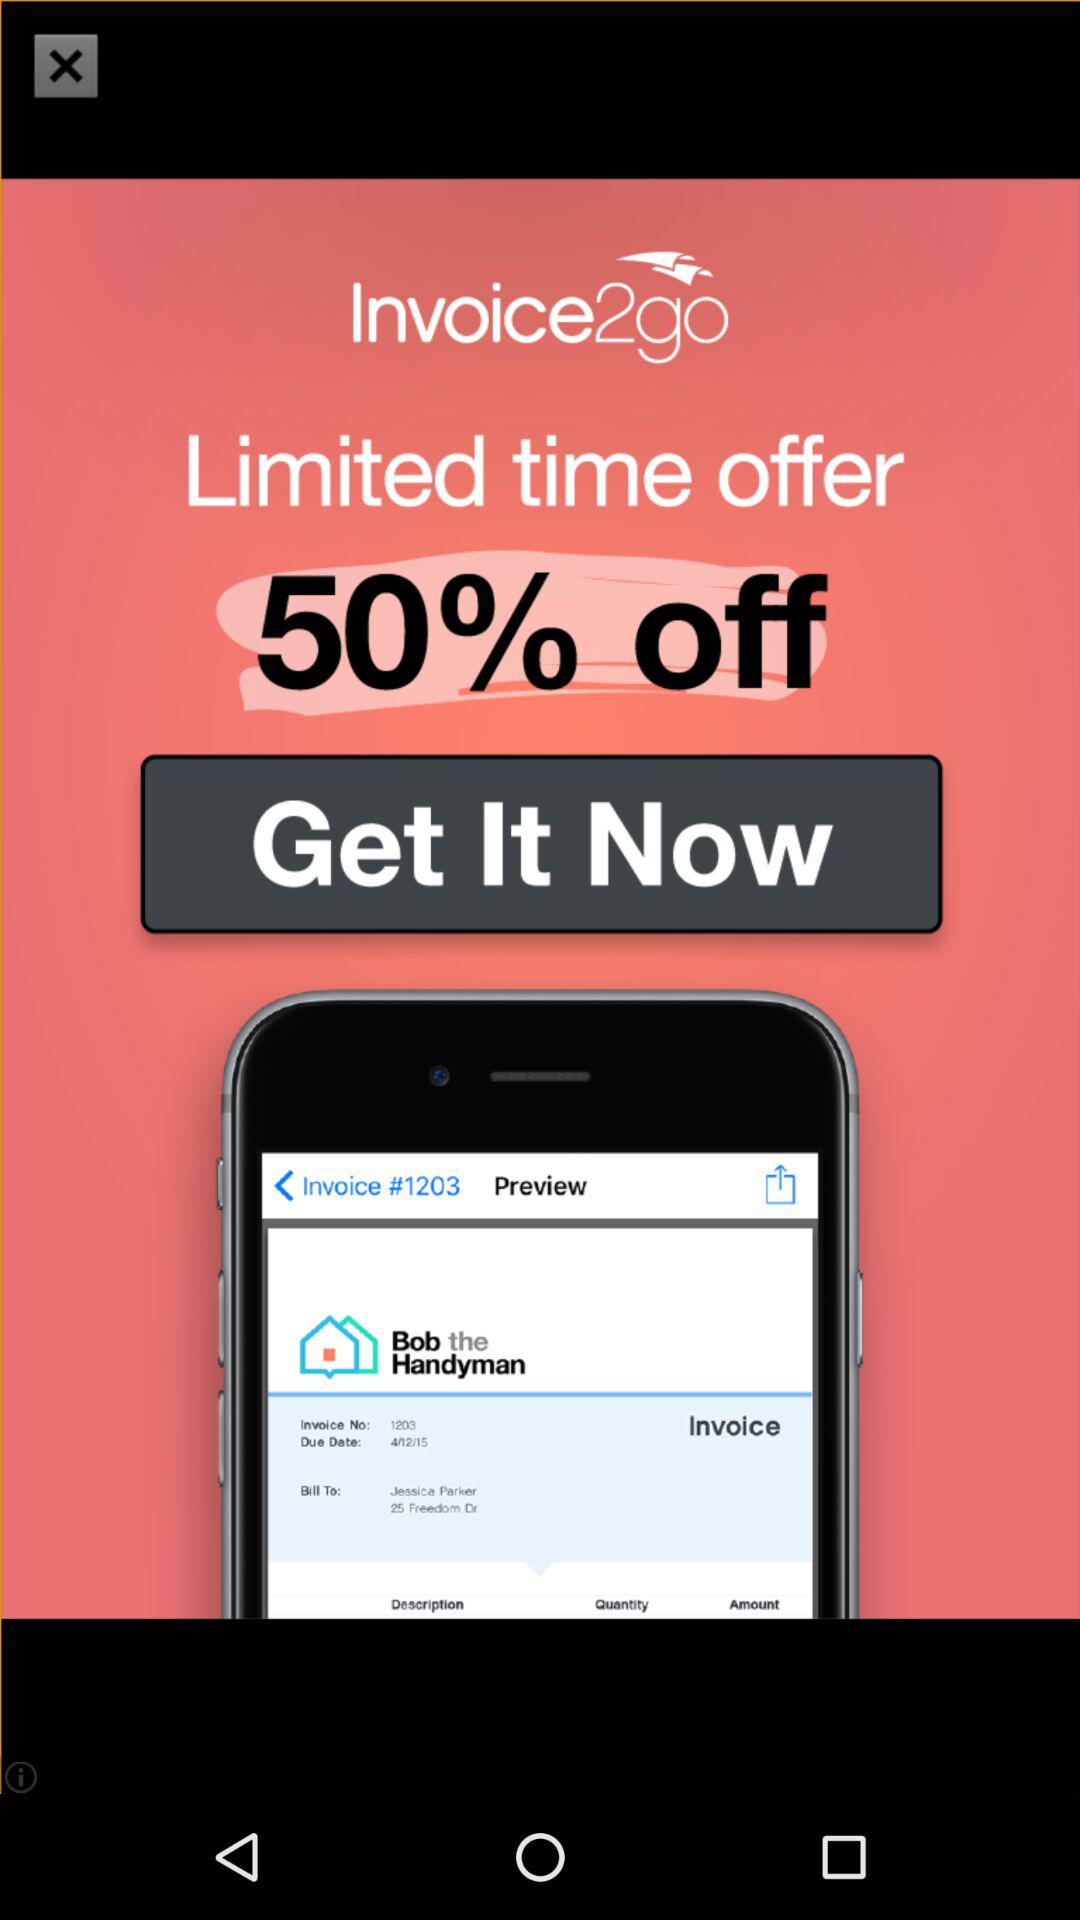How many percent off is the offer?
Answer the question using a single word or phrase. 50% 